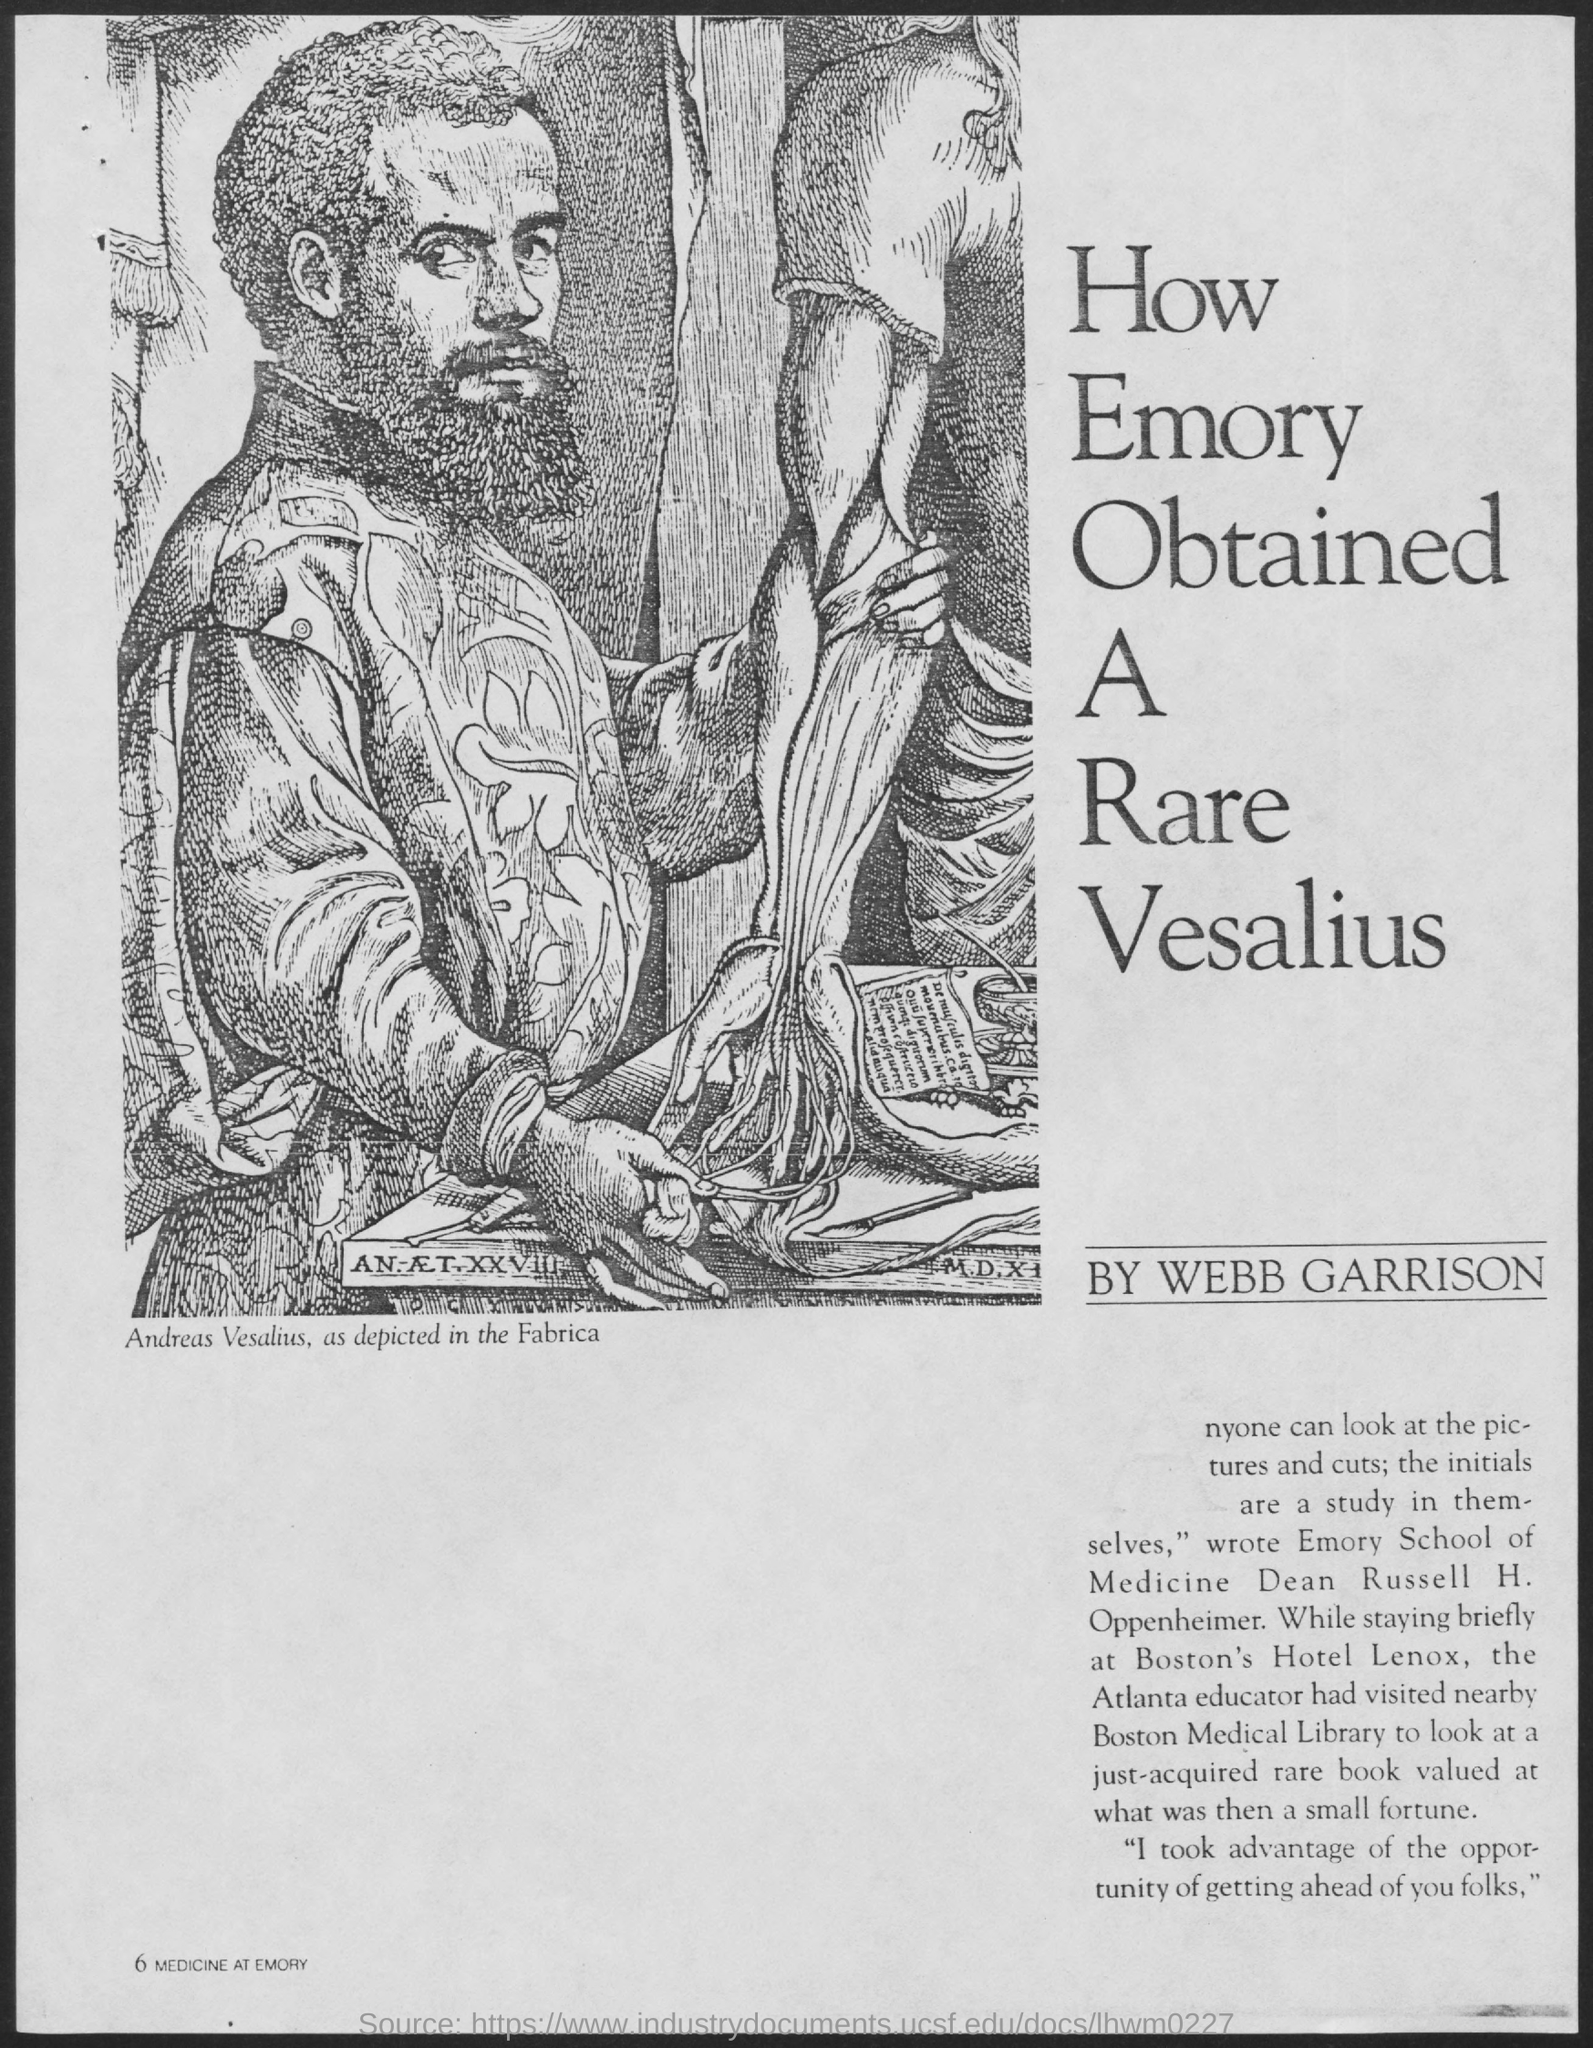What might be the significance of the text 'How Emory Obtained A Rare Vesalius' alongside the image? The text 'How Emory Obtained A Rare Vesalius' likely refers to the acquisition of an important historical medical text by the Emory University School of Medicine. It suggests a story of how an institution significantly enhanced its medical collections, possibly involving interesting narratives of discovery, negotiation, and acquisition of this rare Vesalian work. 